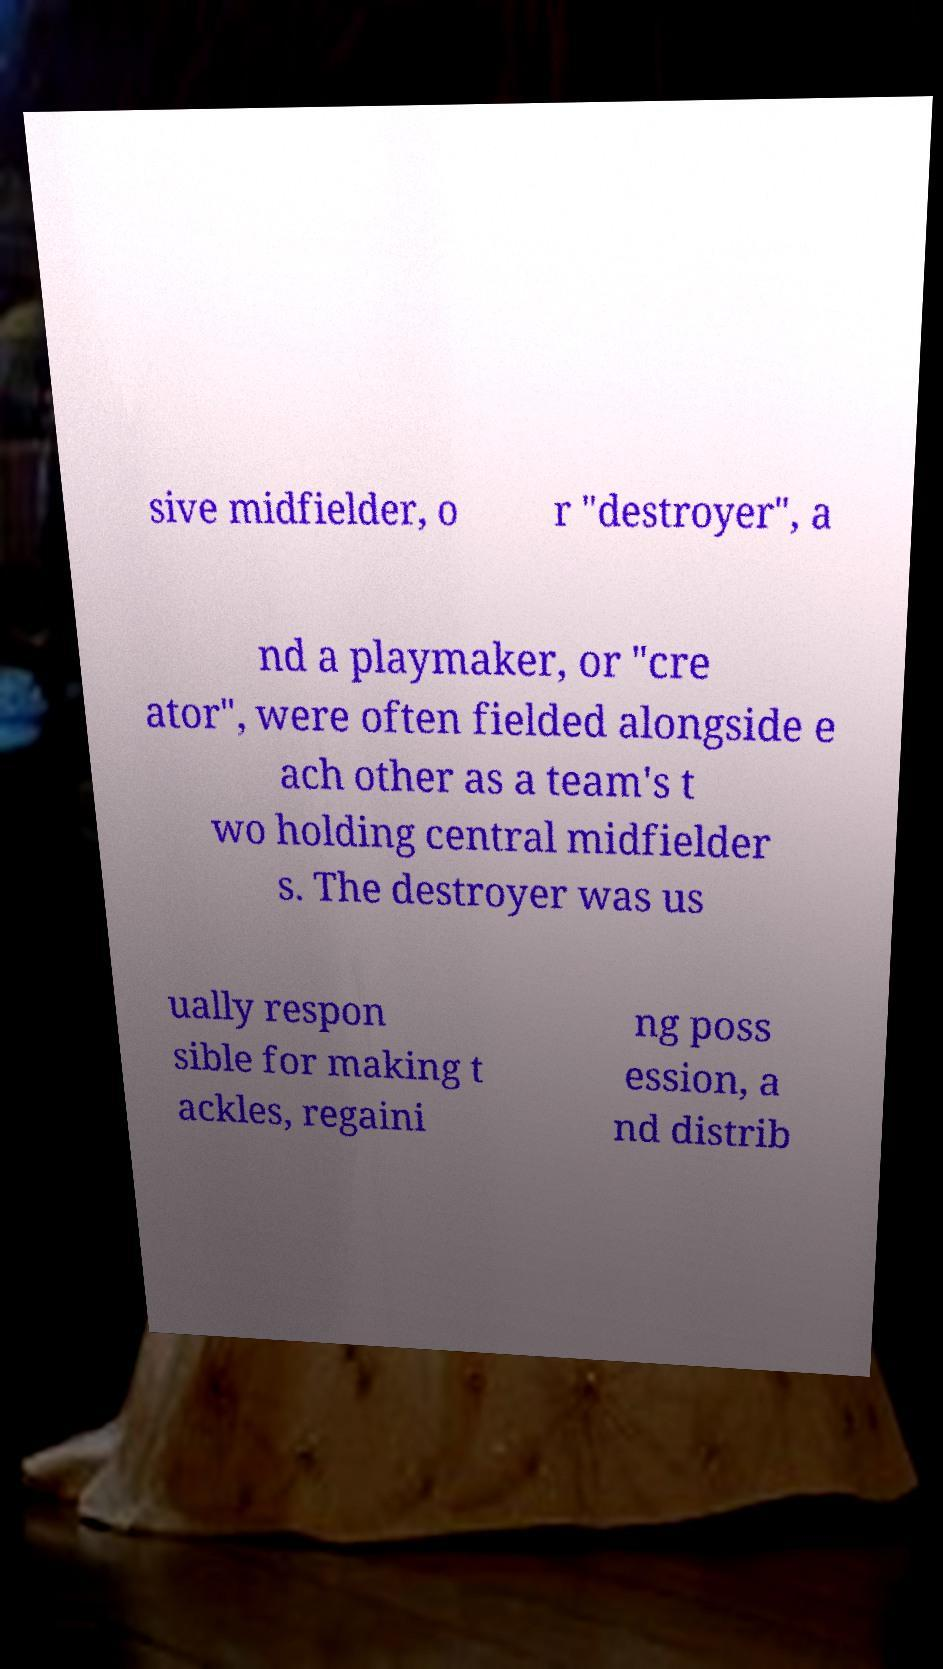Please read and relay the text visible in this image. What does it say? sive midfielder, o r "destroyer", a nd a playmaker, or "cre ator", were often fielded alongside e ach other as a team's t wo holding central midfielder s. The destroyer was us ually respon sible for making t ackles, regaini ng poss ession, a nd distrib 